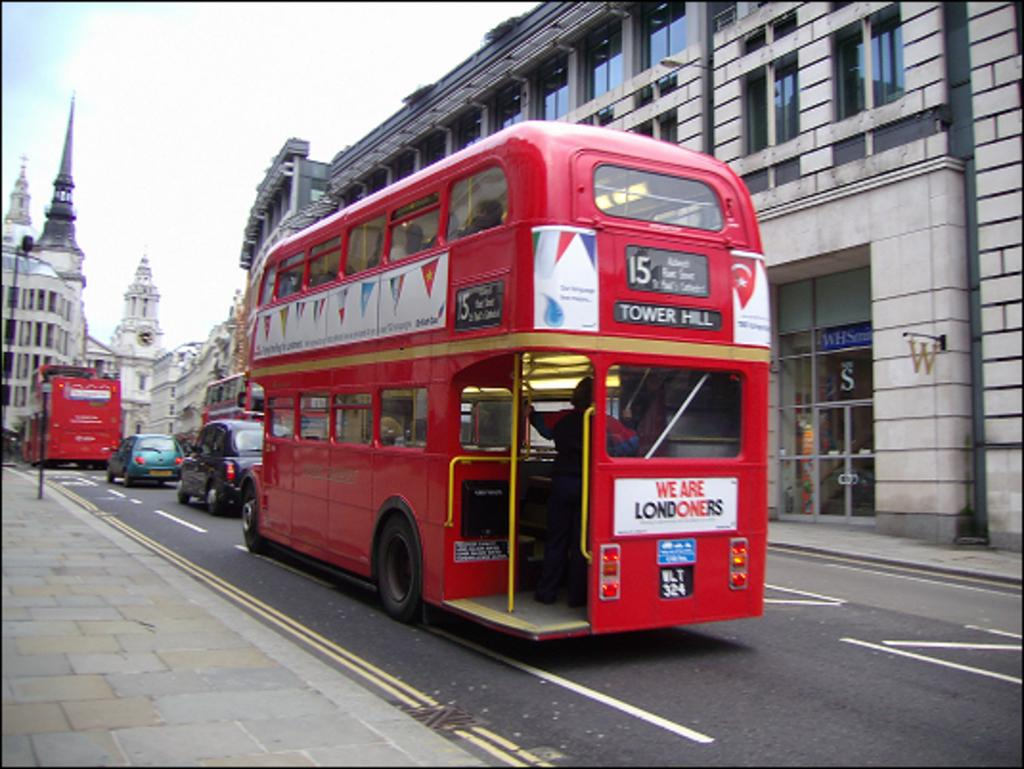<image>
Offer a succinct explanation of the picture presented. A red double decker bus with the sign for Tower Hill is on a London street. 